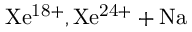Convert formula to latex. <formula><loc_0><loc_0><loc_500><loc_500>X e ^ { 1 8 + } , X e ^ { 2 4 + } + N a</formula> 